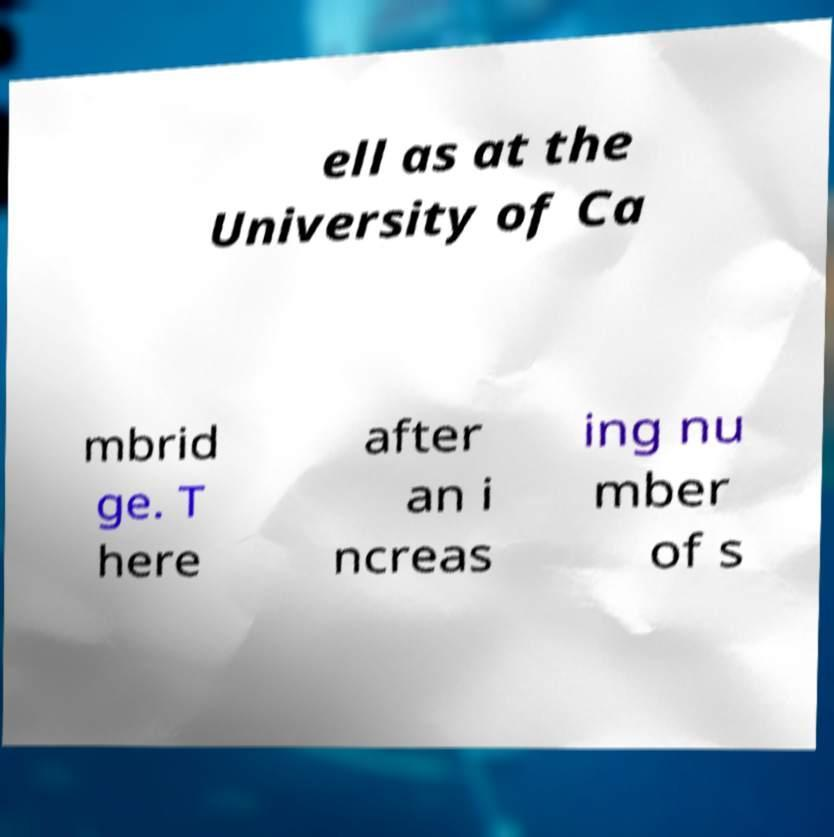What messages or text are displayed in this image? I need them in a readable, typed format. ell as at the University of Ca mbrid ge. T here after an i ncreas ing nu mber of s 